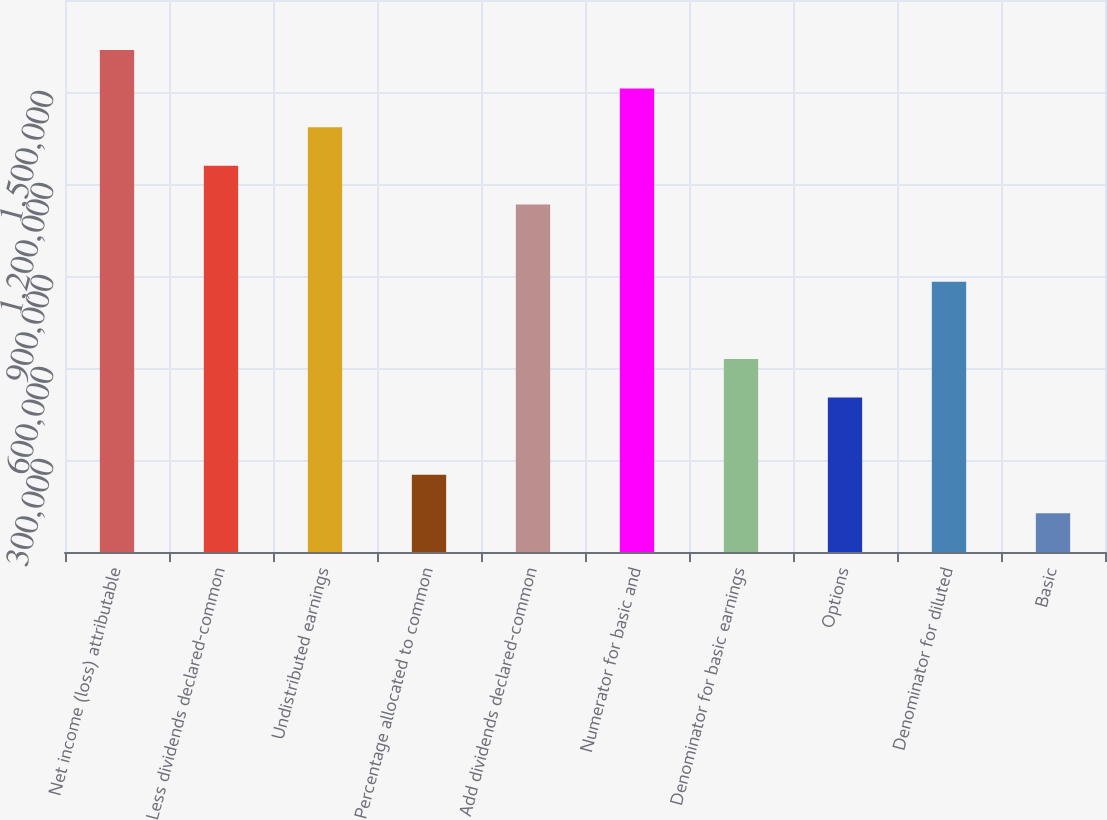<chart> <loc_0><loc_0><loc_500><loc_500><bar_chart><fcel>Net income (loss) attributable<fcel>Less dividends declared-common<fcel>Undistributed earnings<fcel>Percentage allocated to common<fcel>Add dividends declared-common<fcel>Numerator for basic and<fcel>Denominator for basic earnings<fcel>Options<fcel>Denominator for diluted<fcel>Basic<nl><fcel>1.63719e+06<fcel>1.25938e+06<fcel>1.38532e+06<fcel>251897<fcel>1.13345e+06<fcel>1.51125e+06<fcel>629704<fcel>503768<fcel>881575<fcel>125961<nl></chart> 